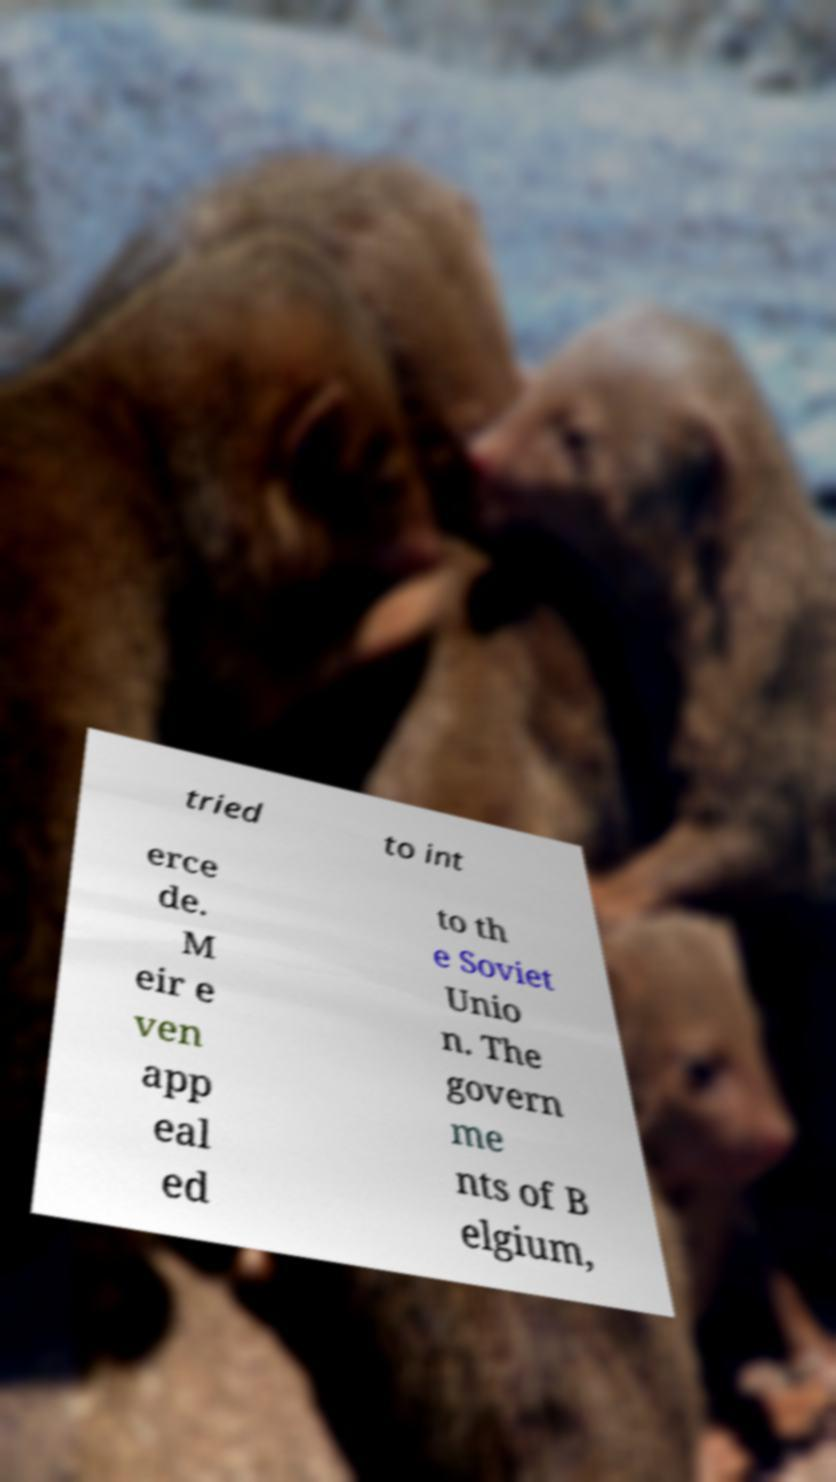Can you accurately transcribe the text from the provided image for me? tried to int erce de. M eir e ven app eal ed to th e Soviet Unio n. The govern me nts of B elgium, 